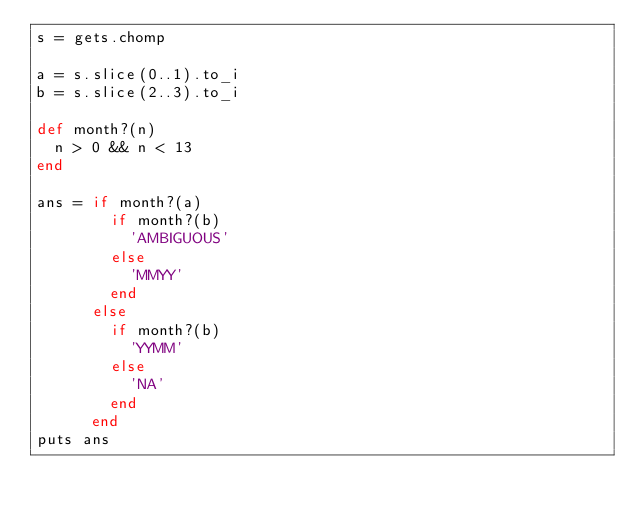Convert code to text. <code><loc_0><loc_0><loc_500><loc_500><_Ruby_>s = gets.chomp

a = s.slice(0..1).to_i
b = s.slice(2..3).to_i

def month?(n)
  n > 0 && n < 13
end

ans = if month?(a)
        if month?(b)
          'AMBIGUOUS'
        else
          'MMYY'
        end
      else
        if month?(b)
          'YYMM'
        else
          'NA'
        end
      end
puts ans
</code> 